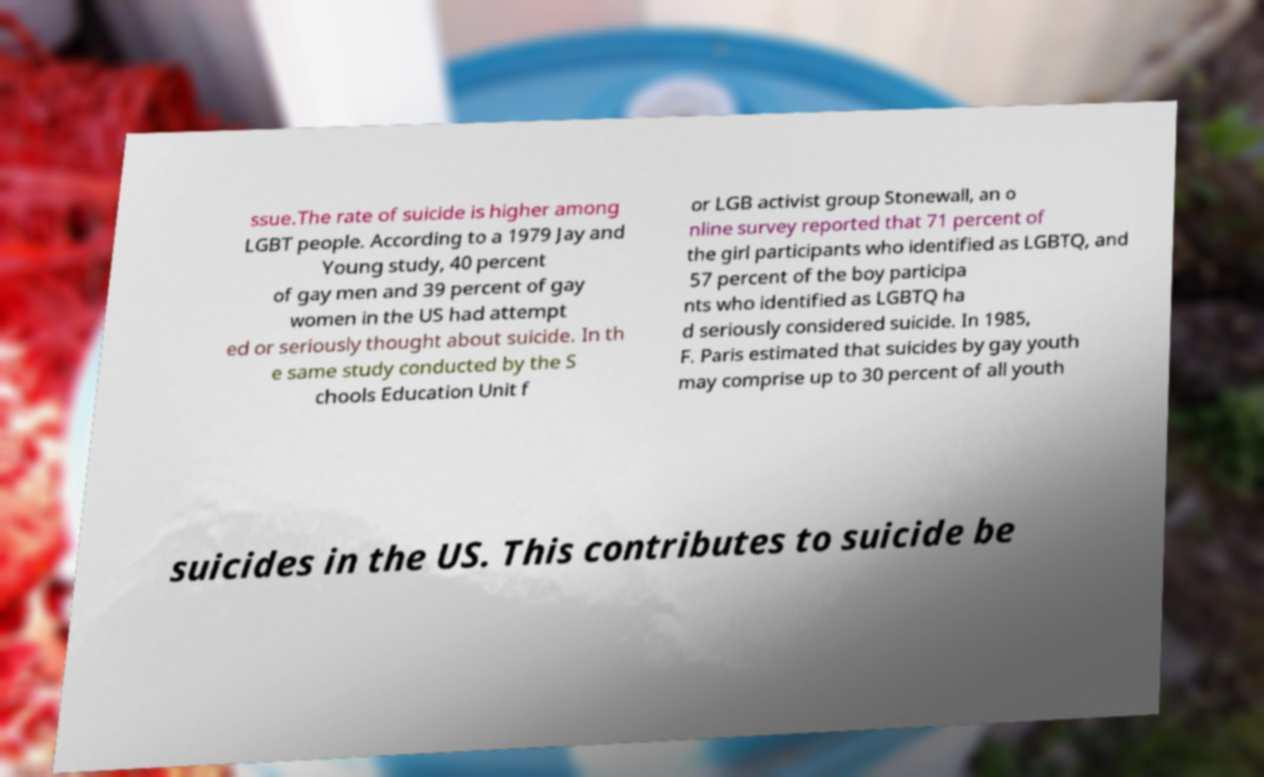Please identify and transcribe the text found in this image. ssue.The rate of suicide is higher among LGBT people. According to a 1979 Jay and Young study, 40 percent of gay men and 39 percent of gay women in the US had attempt ed or seriously thought about suicide. In th e same study conducted by the S chools Education Unit f or LGB activist group Stonewall, an o nline survey reported that 71 percent of the girl participants who identified as LGBTQ, and 57 percent of the boy participa nts who identified as LGBTQ ha d seriously considered suicide. In 1985, F. Paris estimated that suicides by gay youth may comprise up to 30 percent of all youth suicides in the US. This contributes to suicide be 